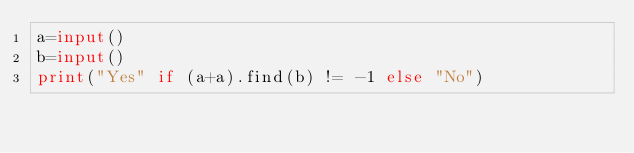<code> <loc_0><loc_0><loc_500><loc_500><_Python_>a=input()
b=input()
print("Yes" if (a+a).find(b) != -1 else "No")
</code> 